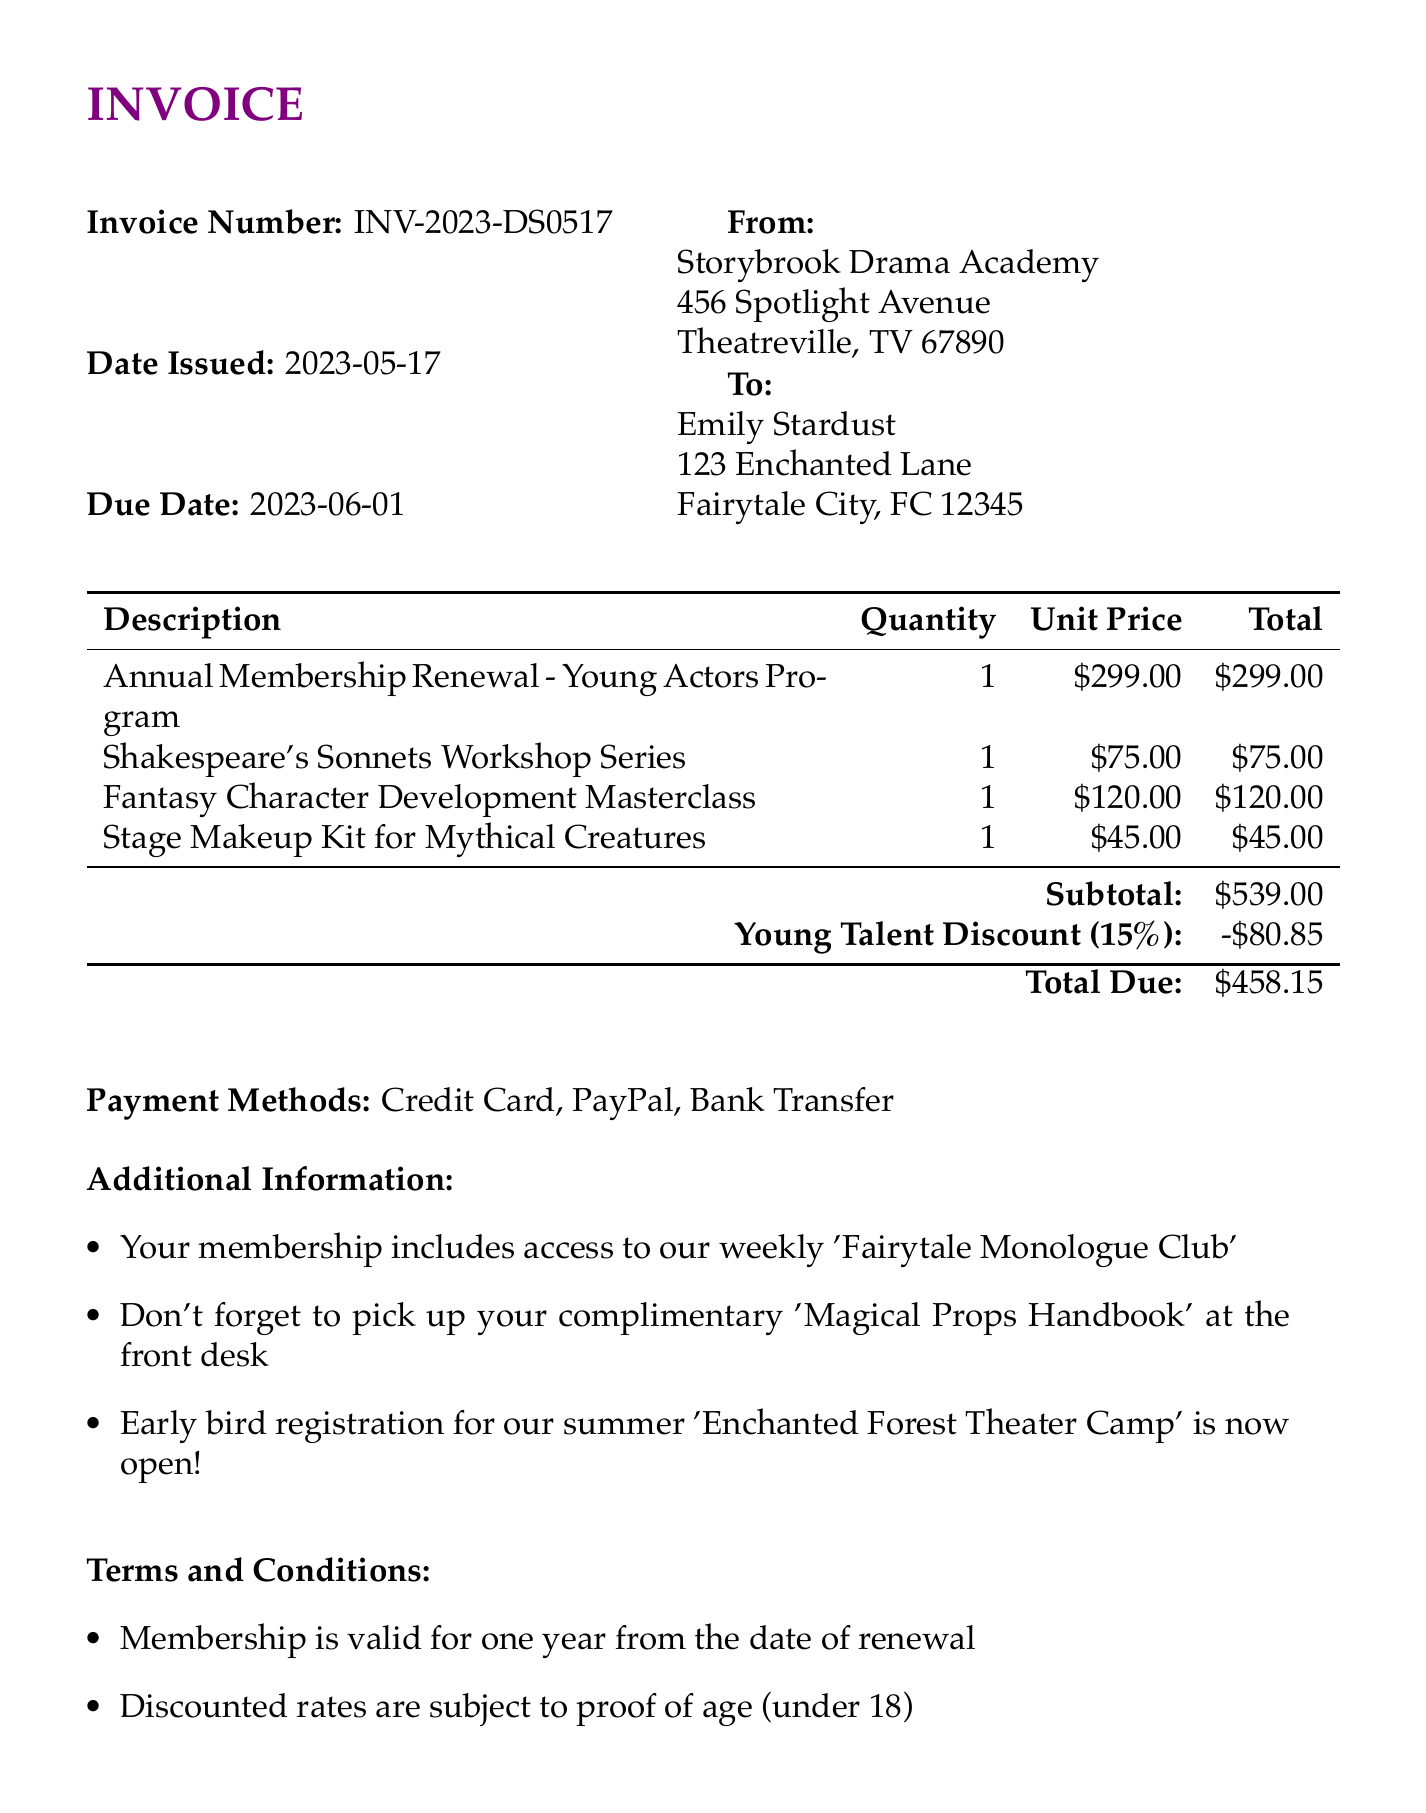What is the invoice number? The invoice number is clearly stated at the top of the document for reference.
Answer: INV-2023-DS0517 Who is the customer? The customer name is displayed in the billing section of the invoice.
Answer: Emily Stardust What is the total due amount? The total amount due is calculated after applying any discounts and is shown prominently towards the end of the invoice.
Answer: 458.15 What is the date issued? The date the invoice was issued is mentioned for tracking payment timelines.
Answer: 2023-05-17 What discount is applied? The document specifies the discount type along with its percentage applied to the total.
Answer: Young Talent Discount (15%) How much is the discount amount? The discount amount is provided as a line item deducting from the subtotal.
Answer: 80.85 What is the address of the drama school? The school's address is listed in the invoice's sender section.
Answer: 456 Spotlight Avenue, Theatreville, TV 67890 Which payment methods are accepted? Payment options are specified clearly to guide the customer on how to complete the payment.
Answer: Credit Card, PayPal, Bank Transfer What is included in the membership? The additional information section details the benefits bundled with the membership.
Answer: Access to our weekly 'Fairytale Monologue Club' 